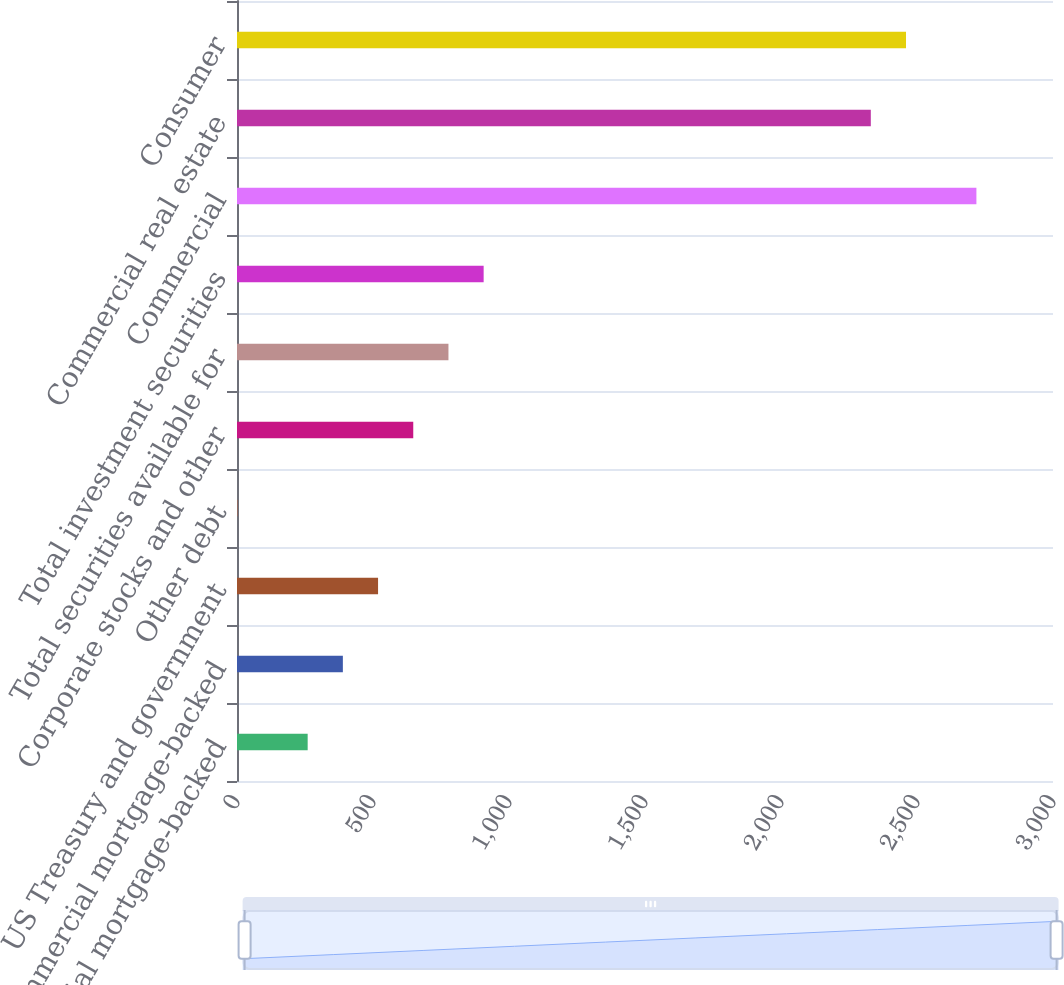Convert chart to OTSL. <chart><loc_0><loc_0><loc_500><loc_500><bar_chart><fcel>Residential mortgage-backed<fcel>Commercial mortgage-backed<fcel>US Treasury and government<fcel>Other debt<fcel>Corporate stocks and other<fcel>Total securities available for<fcel>Total investment securities<fcel>Commercial<fcel>Commercial real estate<fcel>Consumer<nl><fcel>259.8<fcel>389.2<fcel>518.6<fcel>1<fcel>648<fcel>777.4<fcel>906.8<fcel>2718.4<fcel>2330.2<fcel>2459.6<nl></chart> 